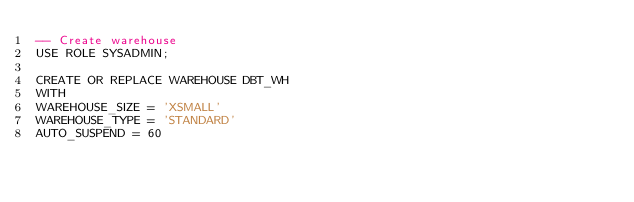<code> <loc_0><loc_0><loc_500><loc_500><_SQL_>-- Create warehouse
USE ROLE SYSADMIN;

CREATE OR REPLACE WAREHOUSE DBT_WH
WITH 
WAREHOUSE_SIZE = 'XSMALL' 
WAREHOUSE_TYPE = 'STANDARD' 
AUTO_SUSPEND = 60 </code> 